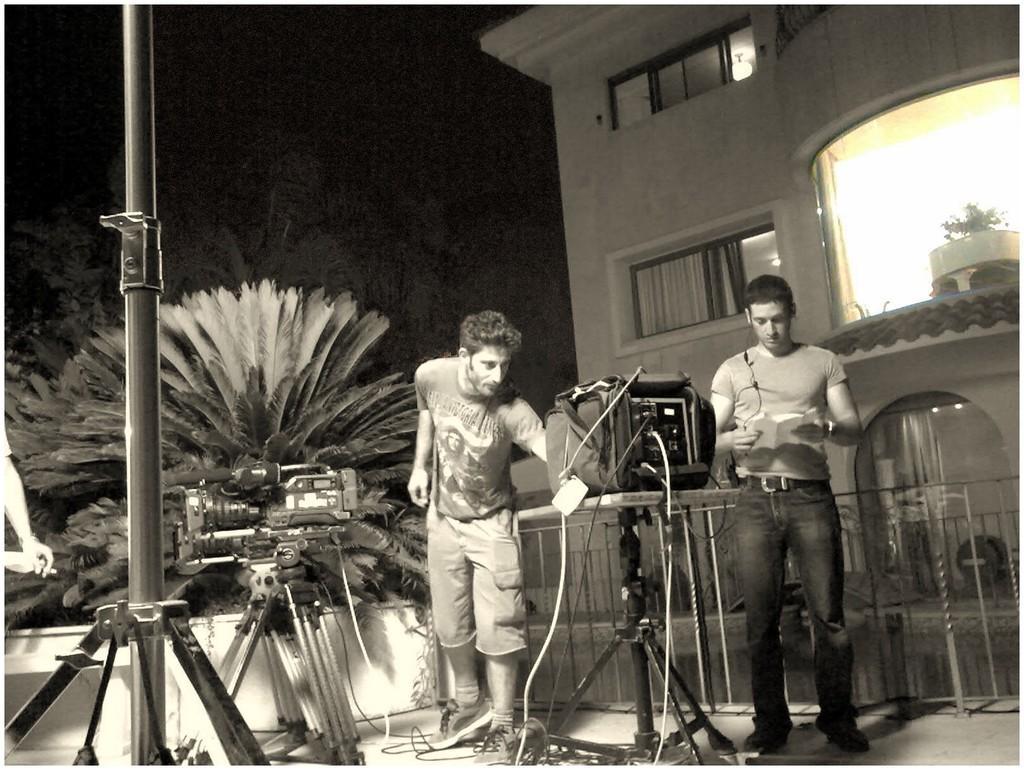How would you summarize this image in a sentence or two? It is the black and white image. In the middle a man is standing, he wore t-shirt, short. On the right side there is a building, on the left side there are trees. 